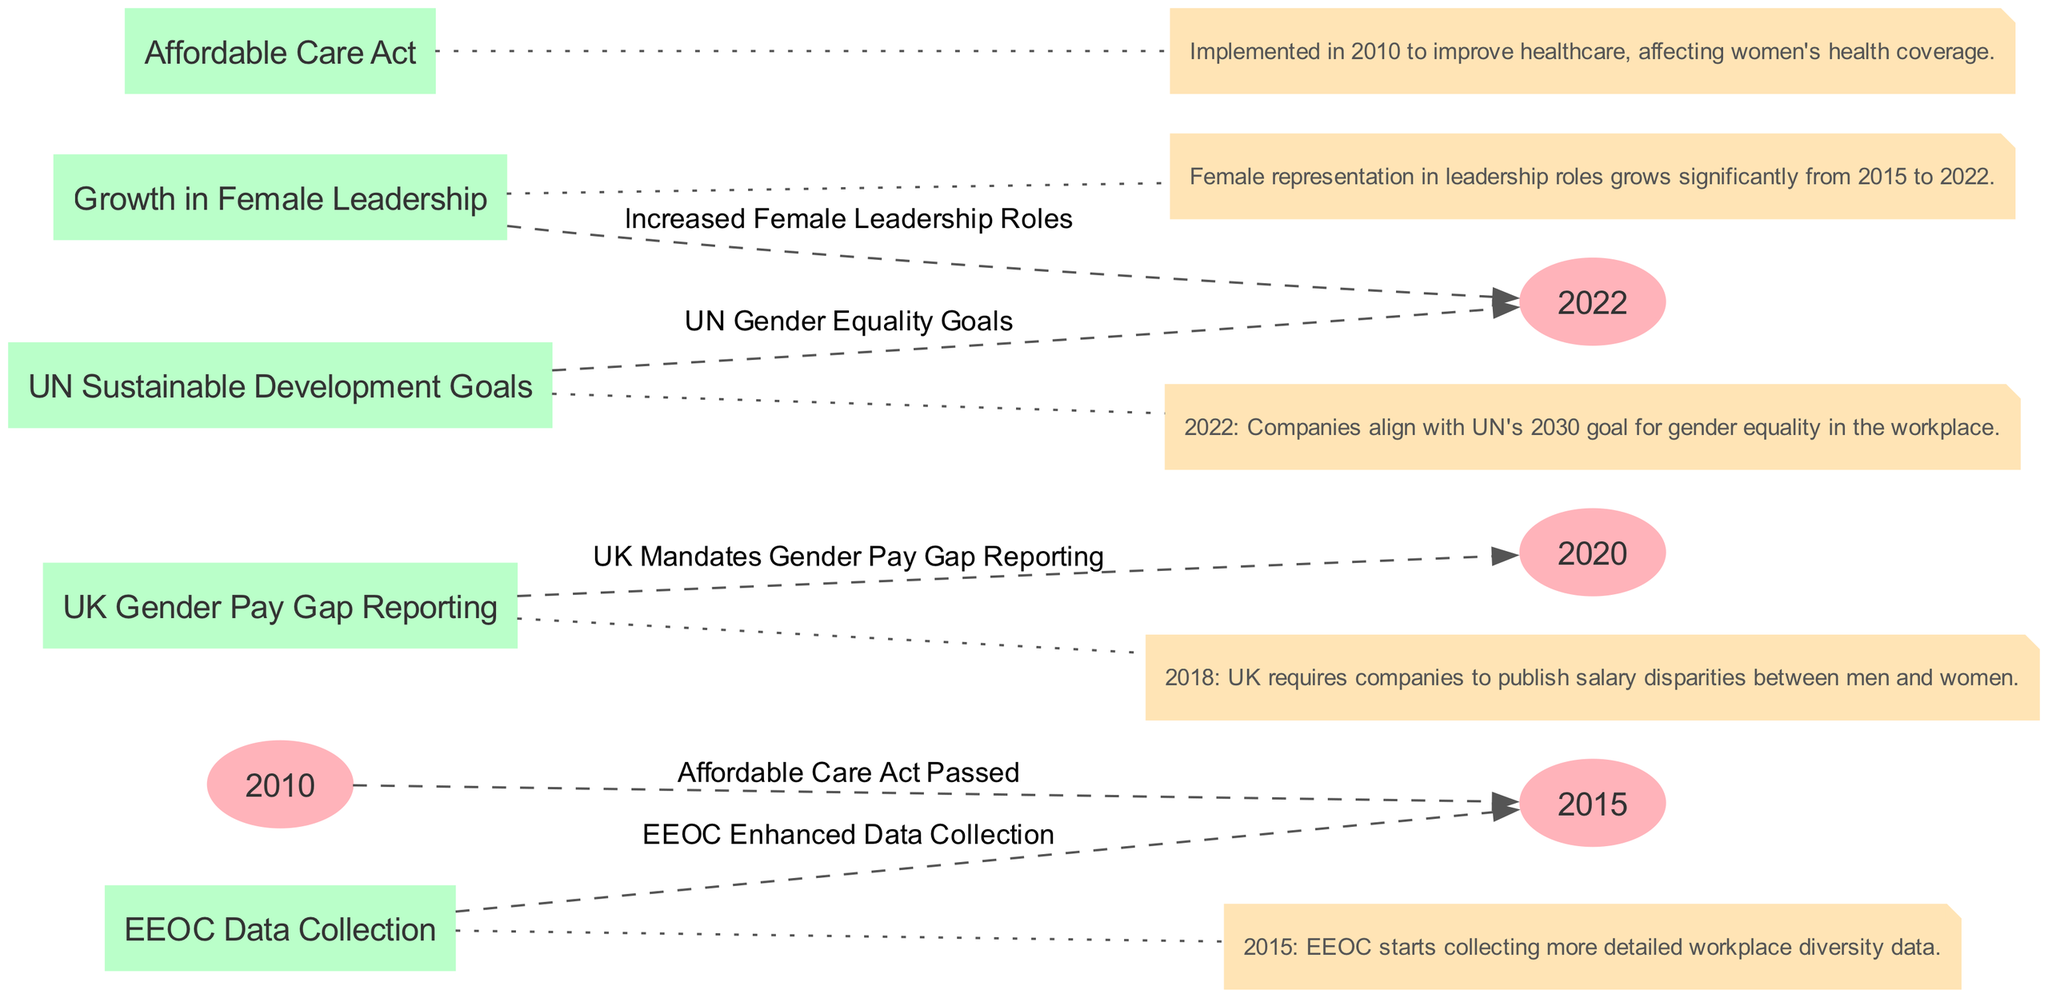What key policy was implemented in 2010 that affects women's health coverage? The diagram indicates that the Affordable Care Act was passed in 2010, which specifically aimed to improve healthcare, including women's health coverage.
Answer: Affordable Care Act How many nodes represent timeline years in the diagram? There are three nodes that represent timeline years: 2010, 2015, 2020, and 2022, which makes it a total of four specific timeline years.
Answer: 4 What event is linked to the year 2015 in the diagram? The diagram shows that the Enhanced Data Collection by the EEOC is linked to the year 2015, indicating a focus on workplace diversity.
Answer: EEOC Enhanced Data Collection Which event corresponds with UK mandates about gender pay? The diagram notes that the UK Gender Pay Gap Reporting mandates correspond with the year 2020, highlighting a significant policy change in the UK.
Answer: UK Gender Pay Gap Reporting Which two nodes are connected by the edge labeled “Increased Female Leadership Roles”? The edge labeled "Increased Female Leadership Roles" connects the node representing female leadership growth to the year 2022, illustrating the progression in female leadership.
Answer: 2022 and Growth in Female Leadership What is the significance of the UN's goal in 2022 as per the diagram? The annotation associated with the UN Sustainable Development Goals in 2022 details that companies align with the UN's goal for gender equality, indicating a worldwide objective.
Answer: UN Gender Equality Goals What represents the relationship between 2015 and the EEOC Data Collection? The edge linking 2015 to EEOC Data Collection shows that the EEOC started enhanced data collection in 2015, indicating a significant step towards improving workplace diversity data.
Answer: EEOC Enhanced Data Collection How many edges are displayed in the diagram? The diagram displays a total of five edges connecting the various events and timeline years, indicating the relationships between them.
Answer: 5 Which node indicates enhanced data collection by the EEOC? The EEOC Enhanced Data Collection node indicates the initiative taken during 2015 to improve the understanding of workplace diversity.
Answer: EEOC Enhanced Data Collection 